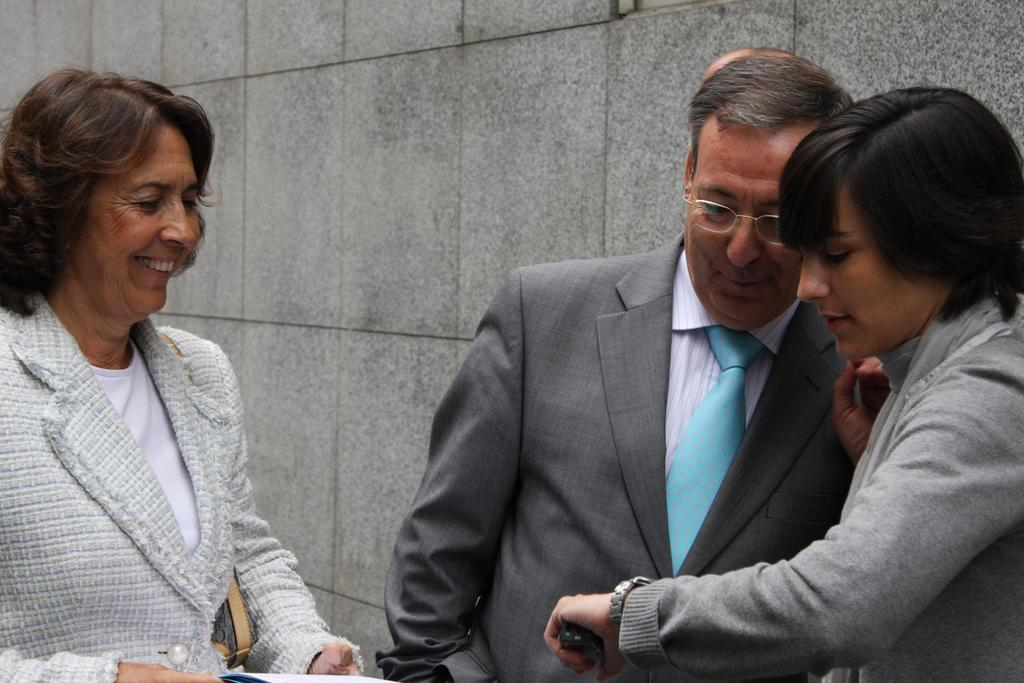How many people are in the image? There are three persons in the image. What is the middle person wearing? The middle person is wearing glasses (specs). What accessory is the person on the right wearing? The person on the right is wearing a watch. What can be seen in the background of the image? There is a wall in the background of the image. Is there a horse present in the image? No, there is no horse present in the image. What type of test is being conducted in the image? There is no test being conducted in the image; it features three people and a wall in the background. 